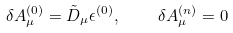Convert formula to latex. <formula><loc_0><loc_0><loc_500><loc_500>\delta A _ { \mu } ^ { ( 0 ) } = \tilde { D } _ { \mu } \epsilon ^ { ( 0 ) } , \quad \delta A _ { \mu } ^ { ( n ) } = 0</formula> 